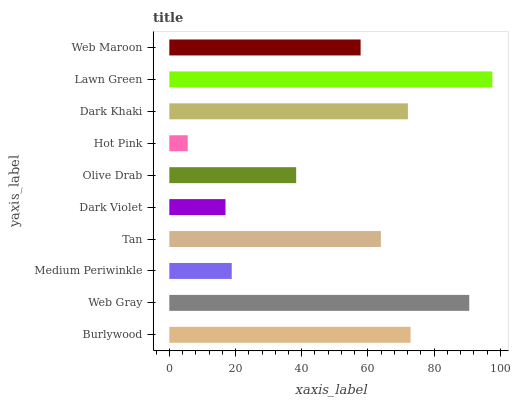Is Hot Pink the minimum?
Answer yes or no. Yes. Is Lawn Green the maximum?
Answer yes or no. Yes. Is Web Gray the minimum?
Answer yes or no. No. Is Web Gray the maximum?
Answer yes or no. No. Is Web Gray greater than Burlywood?
Answer yes or no. Yes. Is Burlywood less than Web Gray?
Answer yes or no. Yes. Is Burlywood greater than Web Gray?
Answer yes or no. No. Is Web Gray less than Burlywood?
Answer yes or no. No. Is Tan the high median?
Answer yes or no. Yes. Is Web Maroon the low median?
Answer yes or no. Yes. Is Hot Pink the high median?
Answer yes or no. No. Is Tan the low median?
Answer yes or no. No. 